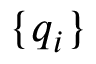<formula> <loc_0><loc_0><loc_500><loc_500>\{ q _ { i } \}</formula> 